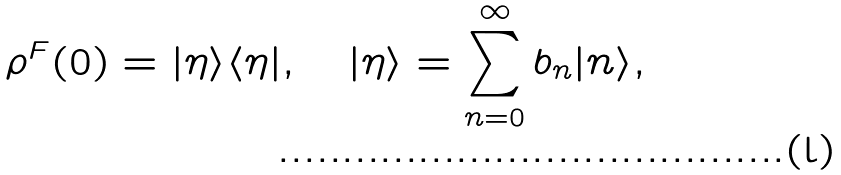Convert formula to latex. <formula><loc_0><loc_0><loc_500><loc_500>\rho ^ { F } ( 0 ) = | \eta \rangle \langle \eta | , \quad | \eta \rangle = \sum _ { n = 0 } ^ { \infty } { b _ { n } } | n \rangle ,</formula> 